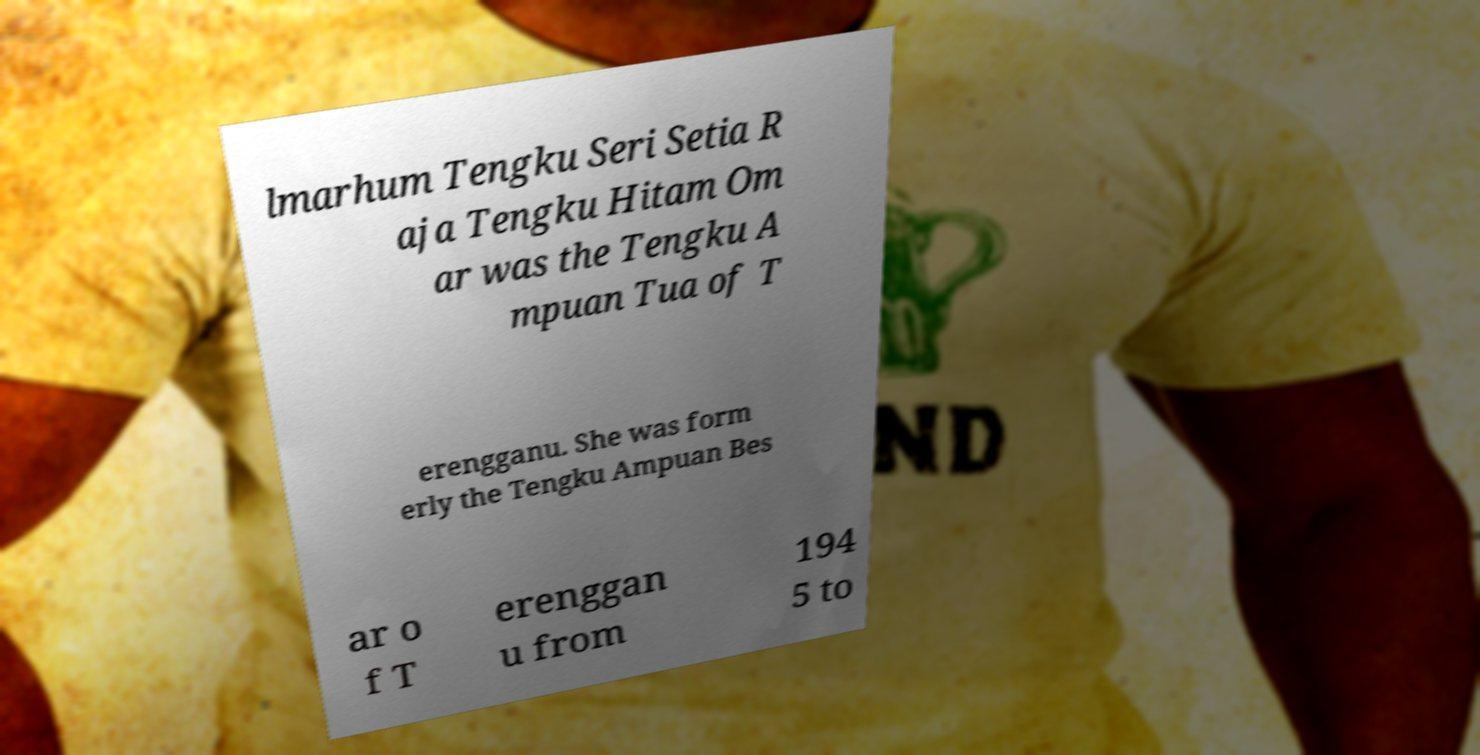For documentation purposes, I need the text within this image transcribed. Could you provide that? lmarhum Tengku Seri Setia R aja Tengku Hitam Om ar was the Tengku A mpuan Tua of T erengganu. She was form erly the Tengku Ampuan Bes ar o f T erenggan u from 194 5 to 